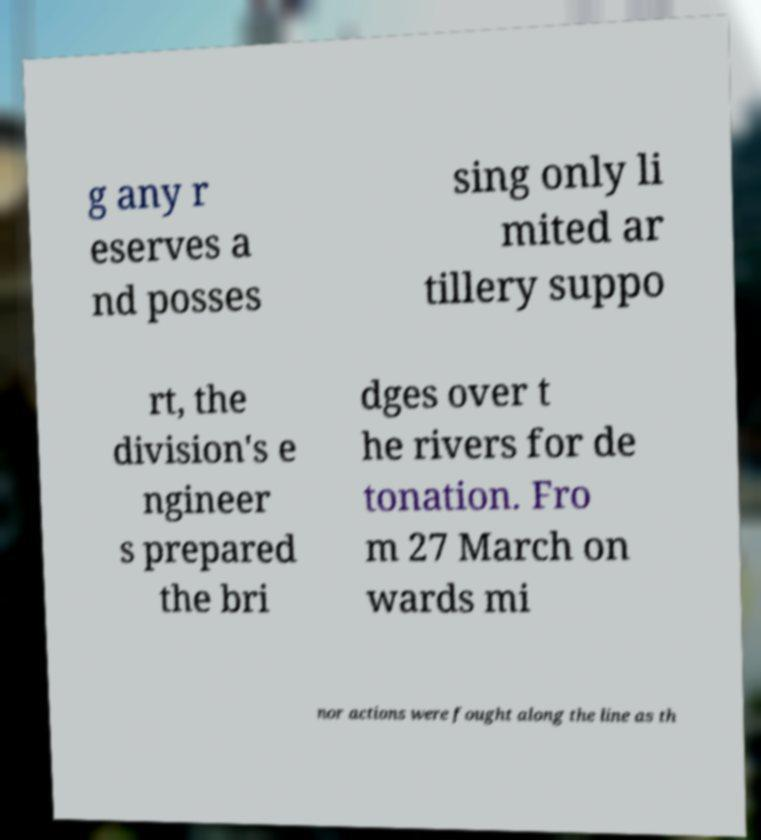Could you assist in decoding the text presented in this image and type it out clearly? g any r eserves a nd posses sing only li mited ar tillery suppo rt, the division's e ngineer s prepared the bri dges over t he rivers for de tonation. Fro m 27 March on wards mi nor actions were fought along the line as th 